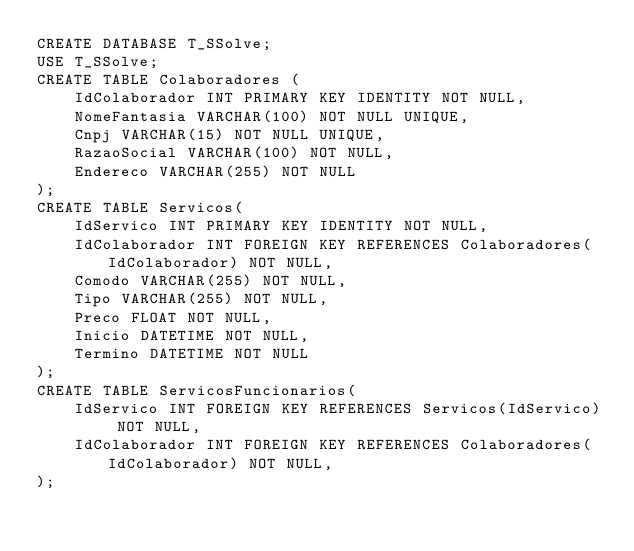Convert code to text. <code><loc_0><loc_0><loc_500><loc_500><_SQL_>CREATE DATABASE T_SSolve;
USE T_SSolve;
CREATE TABLE Colaboradores (
	IdColaborador INT PRIMARY KEY IDENTITY NOT NULL,
	NomeFantasia VARCHAR(100) NOT NULL UNIQUE,
	Cnpj VARCHAR(15) NOT NULL UNIQUE,
	RazaoSocial VARCHAR(100) NOT NULL,
	Endereco VARCHAR(255) NOT NULL
);
CREATE TABLE Servicos(
	IdServico INT PRIMARY KEY IDENTITY NOT NULL,
	IdColaborador INT FOREIGN KEY REFERENCES Colaboradores(IdColaborador) NOT NULL,
	Comodo VARCHAR(255) NOT NULL,
	Tipo VARCHAR(255) NOT NULL,
	Preco FLOAT NOT NULL,
	Inicio DATETIME NOT NULL,
	Termino DATETIME NOT NULL
);
CREATE TABLE ServicosFuncionarios(
	IdServico INT FOREIGN KEY REFERENCES Servicos(IdServico) NOT NULL,
	IdColaborador INT FOREIGN KEY REFERENCES Colaboradores(IdColaborador) NOT NULL,
);


</code> 